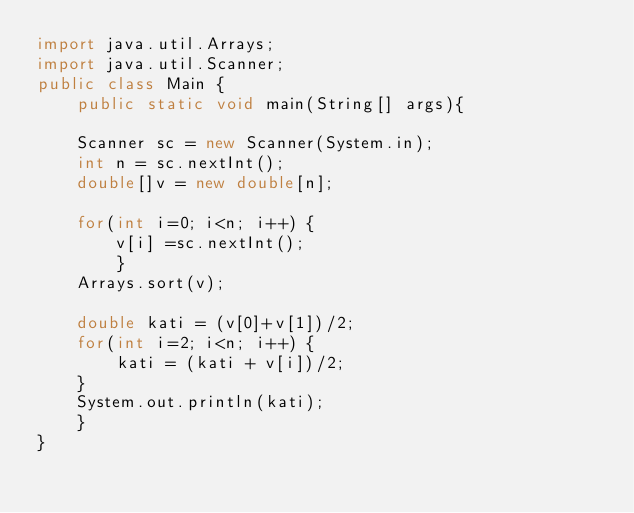Convert code to text. <code><loc_0><loc_0><loc_500><loc_500><_Java_>import java.util.Arrays;
import java.util.Scanner;
public class Main {
    public static void main(String[] args){
    
    Scanner sc = new Scanner(System.in);
    int n = sc.nextInt();
    double[]v = new double[n];

    for(int i=0; i<n; i++) {
    	v[i] =sc.nextInt();
    	}
    Arrays.sort(v);
    
    double kati = (v[0]+v[1])/2;
    for(int i=2; i<n; i++) {
    	kati = (kati + v[i])/2;
    }     	
    System.out.println(kati);
    }
}

</code> 